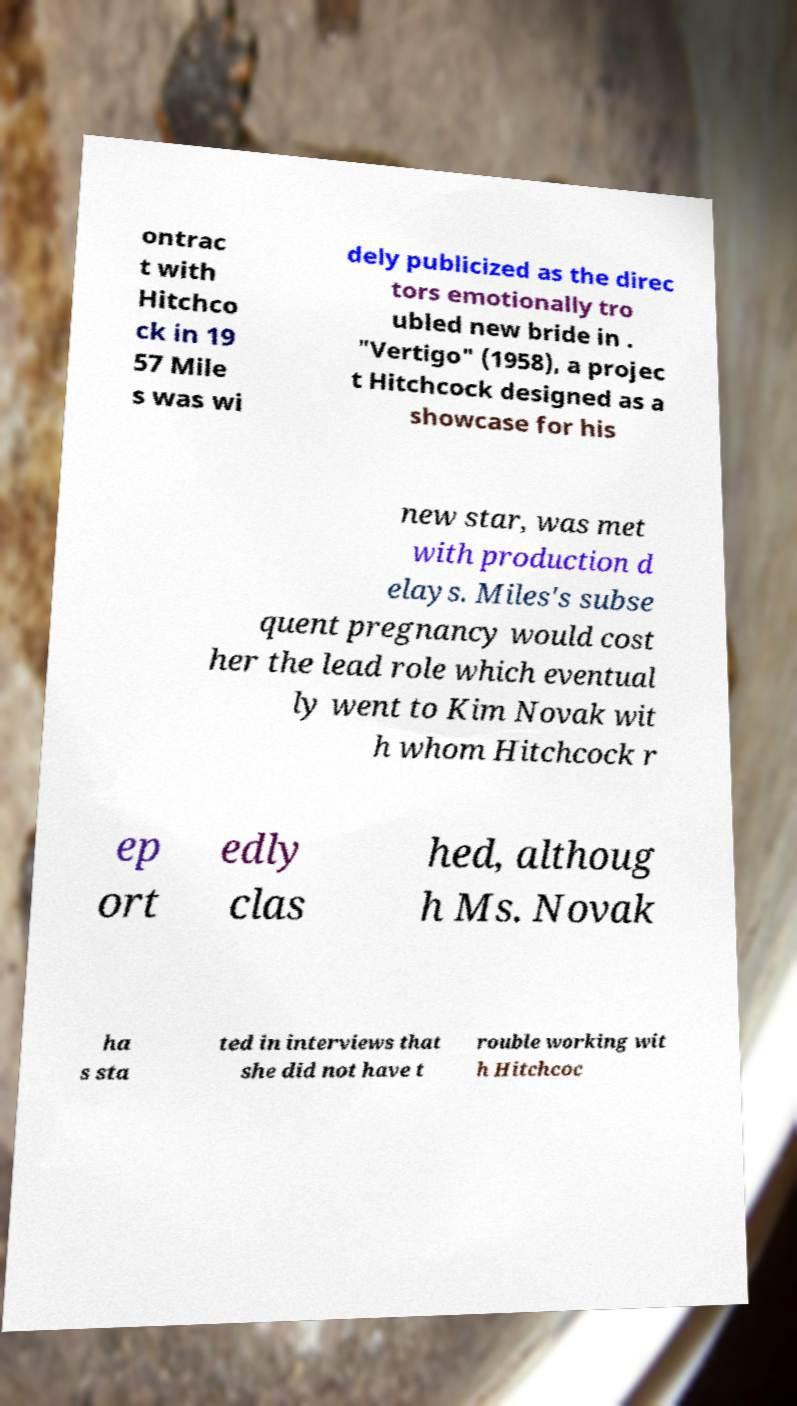I need the written content from this picture converted into text. Can you do that? ontrac t with Hitchco ck in 19 57 Mile s was wi dely publicized as the direc tors emotionally tro ubled new bride in . "Vertigo" (1958), a projec t Hitchcock designed as a showcase for his new star, was met with production d elays. Miles's subse quent pregnancy would cost her the lead role which eventual ly went to Kim Novak wit h whom Hitchcock r ep ort edly clas hed, althoug h Ms. Novak ha s sta ted in interviews that she did not have t rouble working wit h Hitchcoc 